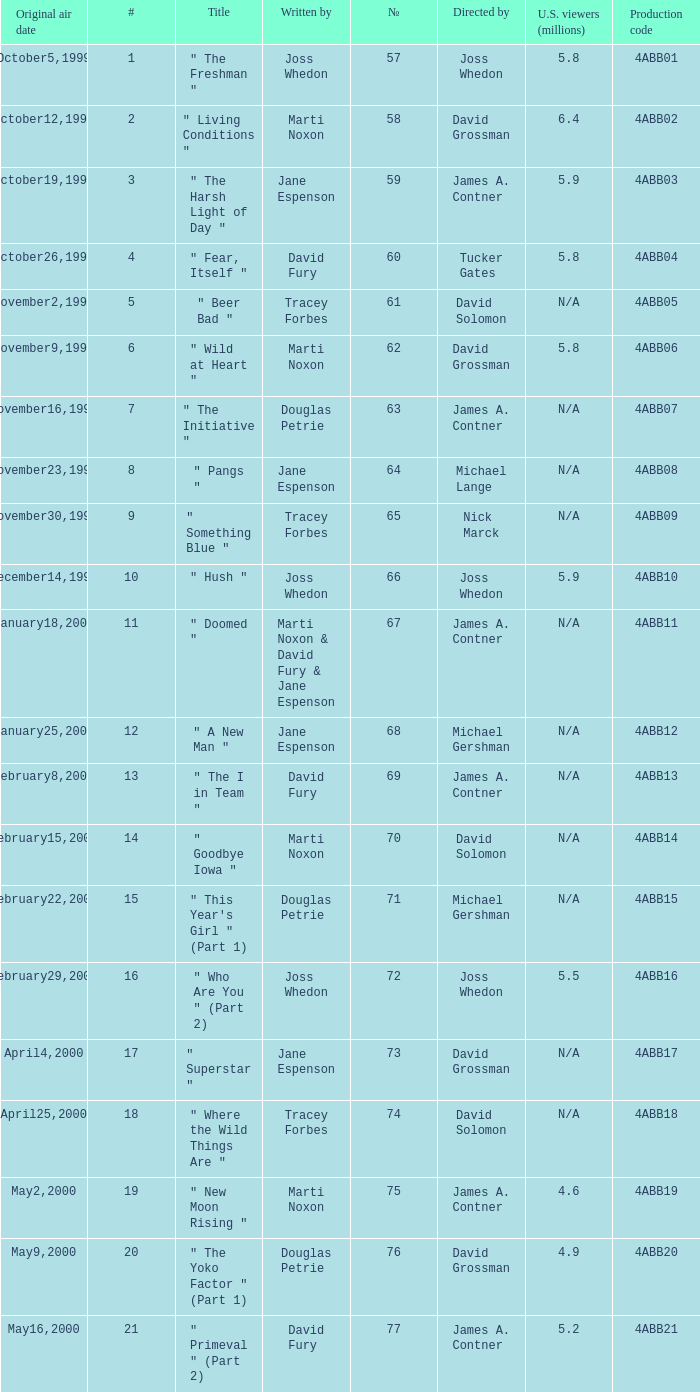Help me parse the entirety of this table. {'header': ['Original air date', '#', 'Title', 'Written by', '№', 'Directed by', 'U.S. viewers (millions)', 'Production code'], 'rows': [['October5,1999', '1', '" The Freshman "', 'Joss Whedon', '57', 'Joss Whedon', '5.8', '4ABB01'], ['October12,1999', '2', '" Living Conditions "', 'Marti Noxon', '58', 'David Grossman', '6.4', '4ABB02'], ['October19,1999', '3', '" The Harsh Light of Day "', 'Jane Espenson', '59', 'James A. Contner', '5.9', '4ABB03'], ['October26,1999', '4', '" Fear, Itself "', 'David Fury', '60', 'Tucker Gates', '5.8', '4ABB04'], ['November2,1999', '5', '" Beer Bad "', 'Tracey Forbes', '61', 'David Solomon', 'N/A', '4ABB05'], ['November9,1999', '6', '" Wild at Heart "', 'Marti Noxon', '62', 'David Grossman', '5.8', '4ABB06'], ['November16,1999', '7', '" The Initiative "', 'Douglas Petrie', '63', 'James A. Contner', 'N/A', '4ABB07'], ['November23,1999', '8', '" Pangs "', 'Jane Espenson', '64', 'Michael Lange', 'N/A', '4ABB08'], ['November30,1999', '9', '" Something Blue "', 'Tracey Forbes', '65', 'Nick Marck', 'N/A', '4ABB09'], ['December14,1999', '10', '" Hush "', 'Joss Whedon', '66', 'Joss Whedon', '5.9', '4ABB10'], ['January18,2000', '11', '" Doomed "', 'Marti Noxon & David Fury & Jane Espenson', '67', 'James A. Contner', 'N/A', '4ABB11'], ['January25,2000', '12', '" A New Man "', 'Jane Espenson', '68', 'Michael Gershman', 'N/A', '4ABB12'], ['February8,2000', '13', '" The I in Team "', 'David Fury', '69', 'James A. Contner', 'N/A', '4ABB13'], ['February15,2000', '14', '" Goodbye Iowa "', 'Marti Noxon', '70', 'David Solomon', 'N/A', '4ABB14'], ['February22,2000', '15', '" This Year\'s Girl " (Part 1)', 'Douglas Petrie', '71', 'Michael Gershman', 'N/A', '4ABB15'], ['February29,2000', '16', '" Who Are You " (Part 2)', 'Joss Whedon', '72', 'Joss Whedon', '5.5', '4ABB16'], ['April4,2000', '17', '" Superstar "', 'Jane Espenson', '73', 'David Grossman', 'N/A', '4ABB17'], ['April25,2000', '18', '" Where the Wild Things Are "', 'Tracey Forbes', '74', 'David Solomon', 'N/A', '4ABB18'], ['May2,2000', '19', '" New Moon Rising "', 'Marti Noxon', '75', 'James A. Contner', '4.6', '4ABB19'], ['May9,2000', '20', '" The Yoko Factor " (Part 1)', 'Douglas Petrie', '76', 'David Grossman', '4.9', '4ABB20'], ['May16,2000', '21', '" Primeval " (Part 2)', 'David Fury', '77', 'James A. Contner', '5.2', '4ABB21']]} What is the season 4 # for the production code of 4abb07? 7.0. 